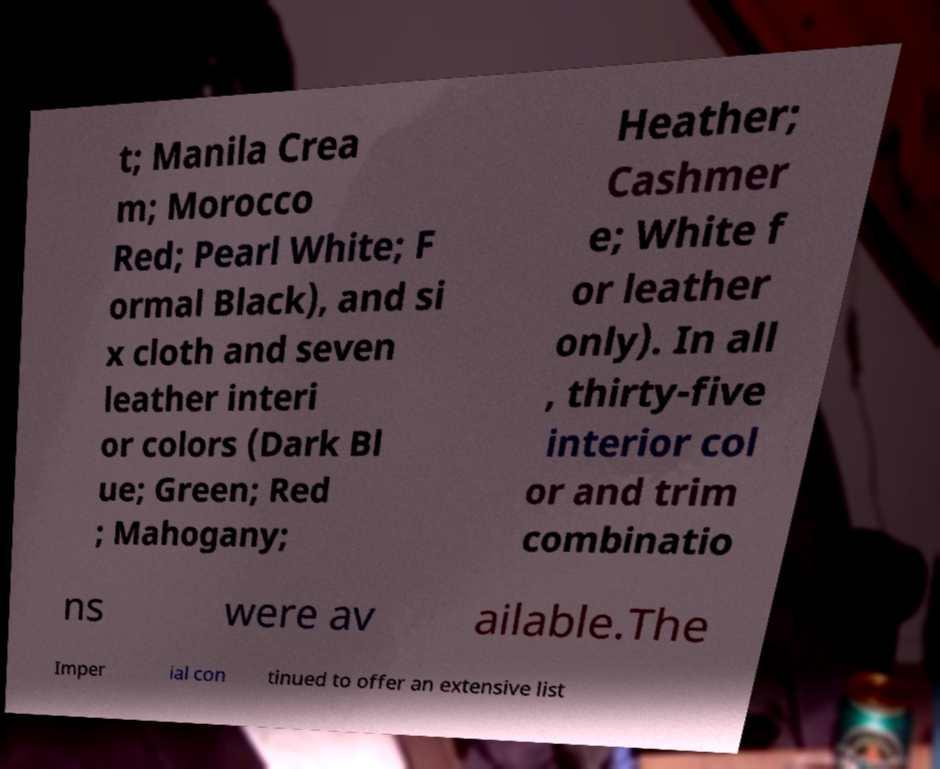Please identify and transcribe the text found in this image. t; Manila Crea m; Morocco Red; Pearl White; F ormal Black), and si x cloth and seven leather interi or colors (Dark Bl ue; Green; Red ; Mahogany; Heather; Cashmer e; White f or leather only). In all , thirty-five interior col or and trim combinatio ns were av ailable.The Imper ial con tinued to offer an extensive list 